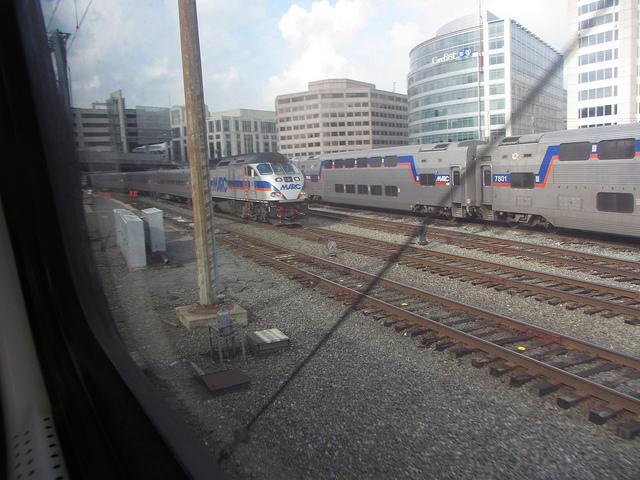Is this in the country or in the city?
Short answer required. City. What color are the train cars?
Be succinct. Silver. Where is the parking garage?
Concise answer only. Behind trains. 